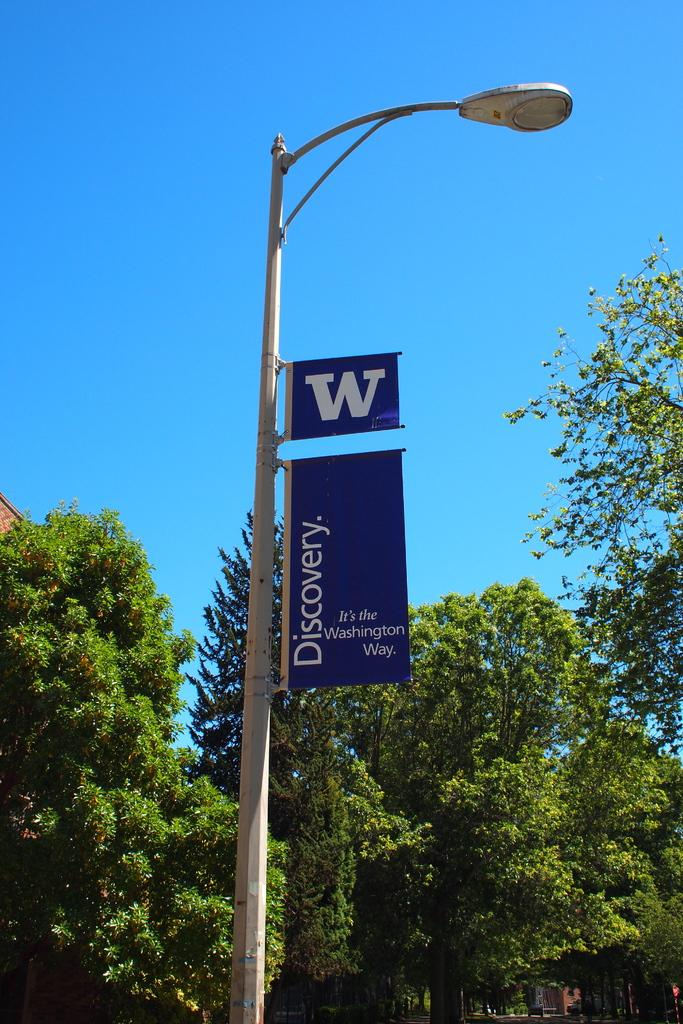What is located in the foreground of the image? There is a street light and boards in the foreground of the image. What can be seen in the middle of the image? There are trees and buildings in the middle of the image. What is visible at the top of the image? The sky is visible at the top of the image. What type of glue is being used to attach the wire to the tree in the image? There is no glue or wire present in the image; it features a street light, boards, trees, buildings, and the sky. How many attempts were made to climb the building in the image? There is no indication of anyone attempting to climb the building in the image. 